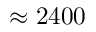<formula> <loc_0><loc_0><loc_500><loc_500>\approx 2 4 0 0</formula> 